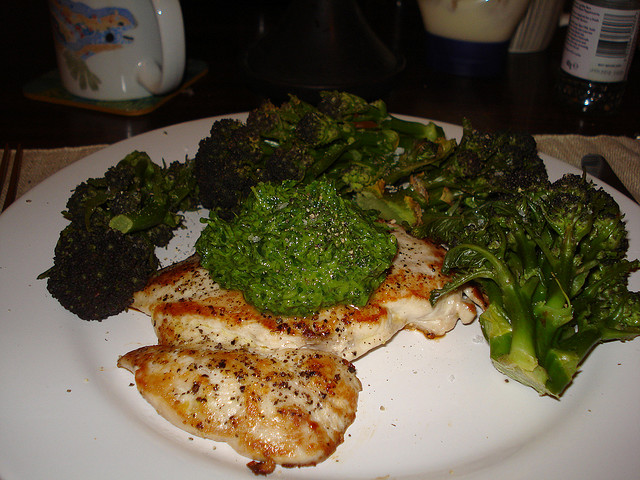<image>What kind of potato are they having with their meal? There is no potato in the image. However, it can be a baked potato. What kind of sauce is on this meat? I don't know what kind of sauce is on the meat. It could be chimichurri, wine, barbecue, or lemon pepper. What kind of potato are they having with their meal? I don't know what kind of potato they are having with their meal. It can be none or baked. What kind of sauce is on this meat? It is unknown what kind of sauce is on this meat. It can be any sauce mentioned or none at all. 